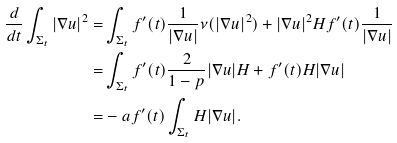Convert formula to latex. <formula><loc_0><loc_0><loc_500><loc_500>\frac { d } { d t } \int _ { \Sigma _ { t } } | \nabla u | ^ { 2 } = & \int _ { \Sigma _ { t } } f ^ { \prime } ( t ) \frac { 1 } { | \nabla u | } \nu ( | \nabla u | ^ { 2 } ) + | \nabla u | ^ { 2 } H f ^ { \prime } ( t ) \frac { 1 } { | \nabla u | } \\ = & \int _ { \Sigma _ { t } } f ^ { \prime } ( t ) \frac { 2 } { 1 - p } | \nabla u | H + f ^ { \prime } ( t ) H | \nabla u | \\ = & - a f ^ { \prime } ( t ) \int _ { \Sigma _ { t } } H | \nabla u | .</formula> 